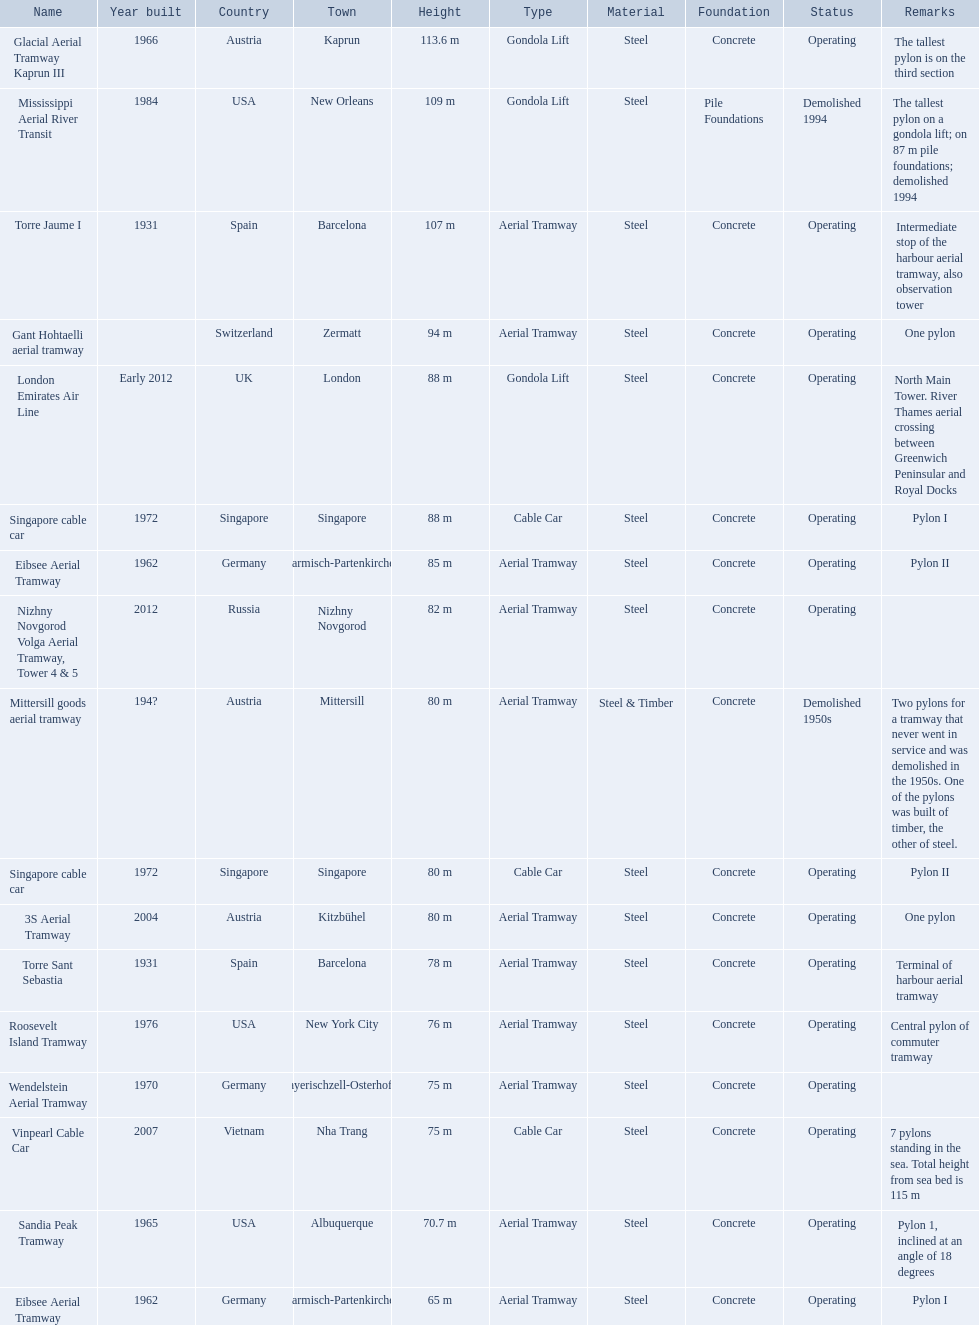How many aerial lift pylon's on the list are located in the usa? Mississippi Aerial River Transit, Roosevelt Island Tramway, Sandia Peak Tramway. Of the pylon's located in the usa how many were built after 1970? Mississippi Aerial River Transit, Roosevelt Island Tramway. Of the pylon's built after 1970 which is the tallest pylon on a gondola lift? Mississippi Aerial River Transit. How many meters is the tallest pylon on a gondola lift? 109 m. 